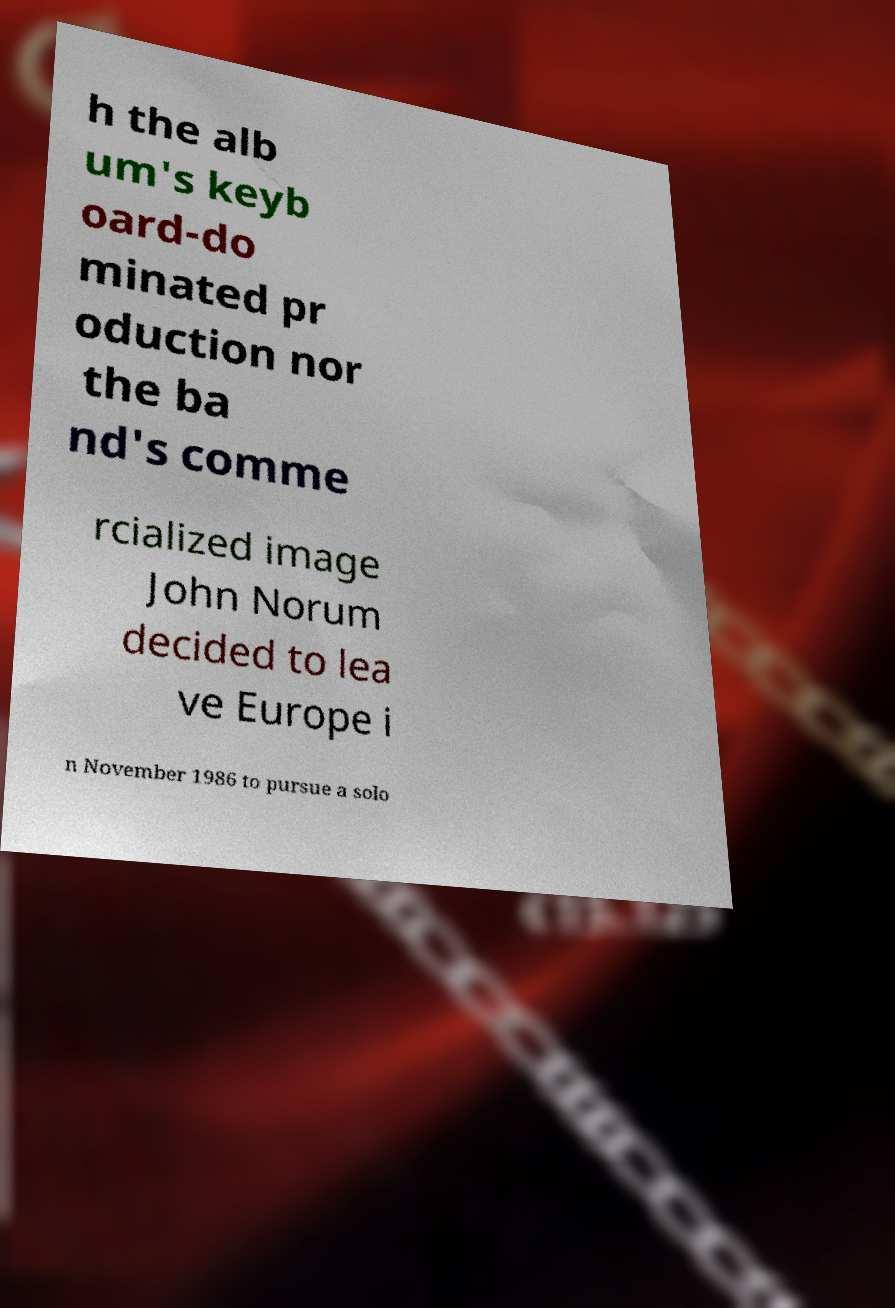Please identify and transcribe the text found in this image. h the alb um's keyb oard-do minated pr oduction nor the ba nd's comme rcialized image John Norum decided to lea ve Europe i n November 1986 to pursue a solo 